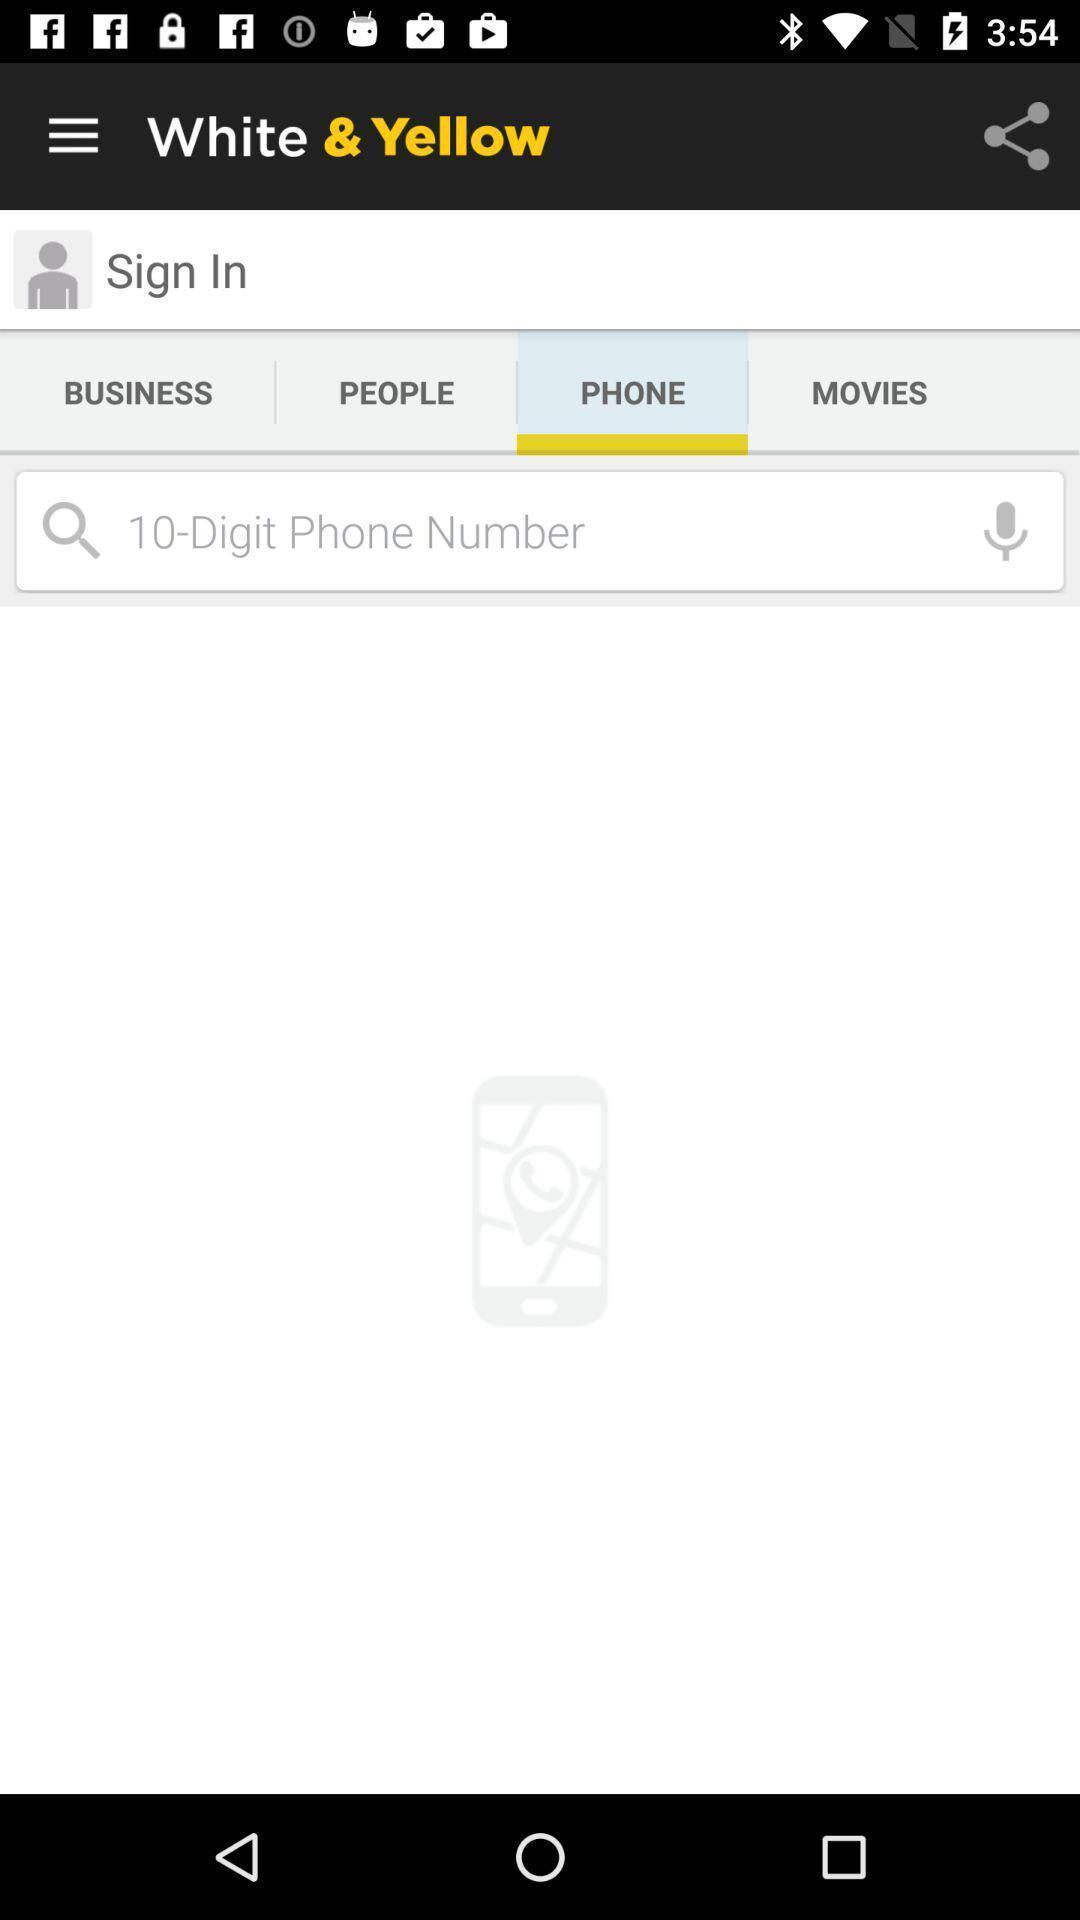Explain the elements present in this screenshot. Sign-in page of a business application. 